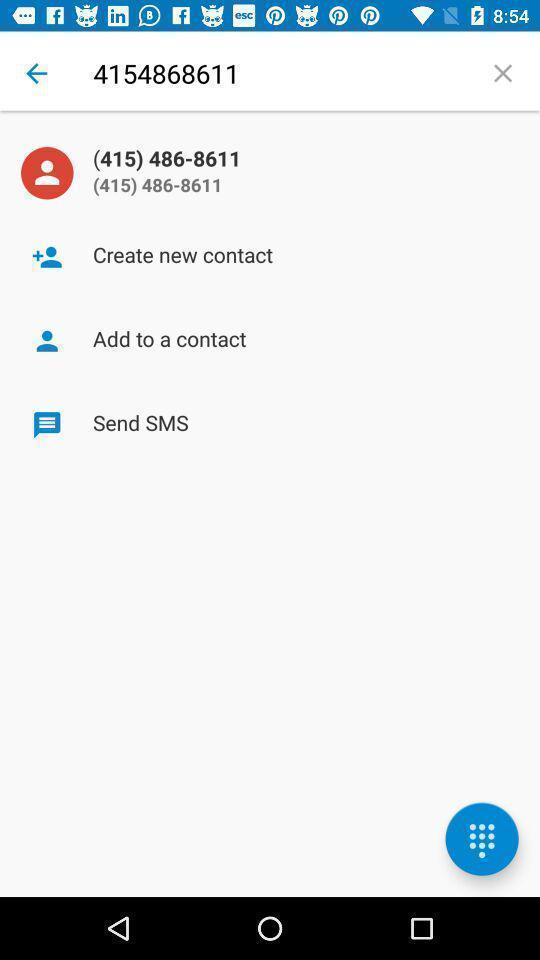Describe this image in words. Page to add phone number in the contact app. 